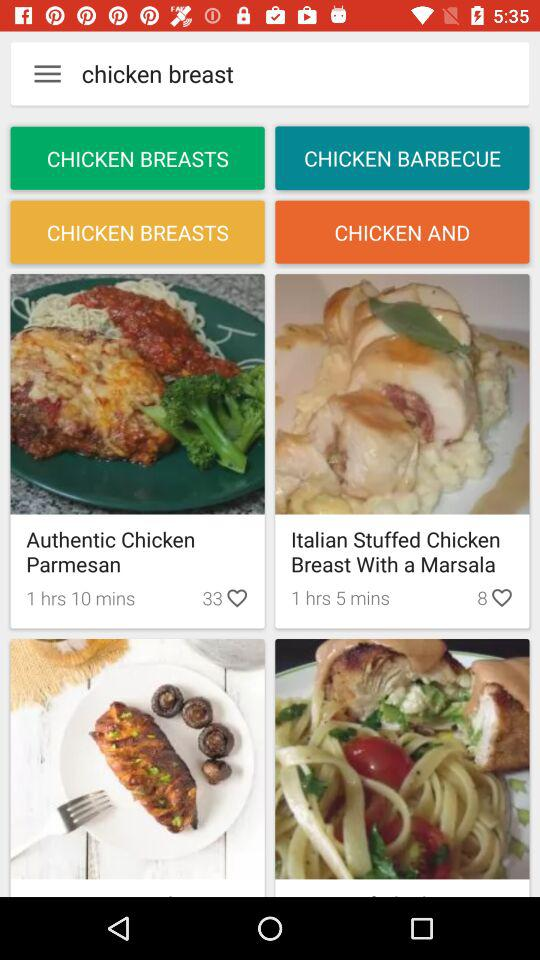How much time dark chocolate yogurt cake takes to deliver?
When the provided information is insufficient, respond with <no answer>. <no answer> 